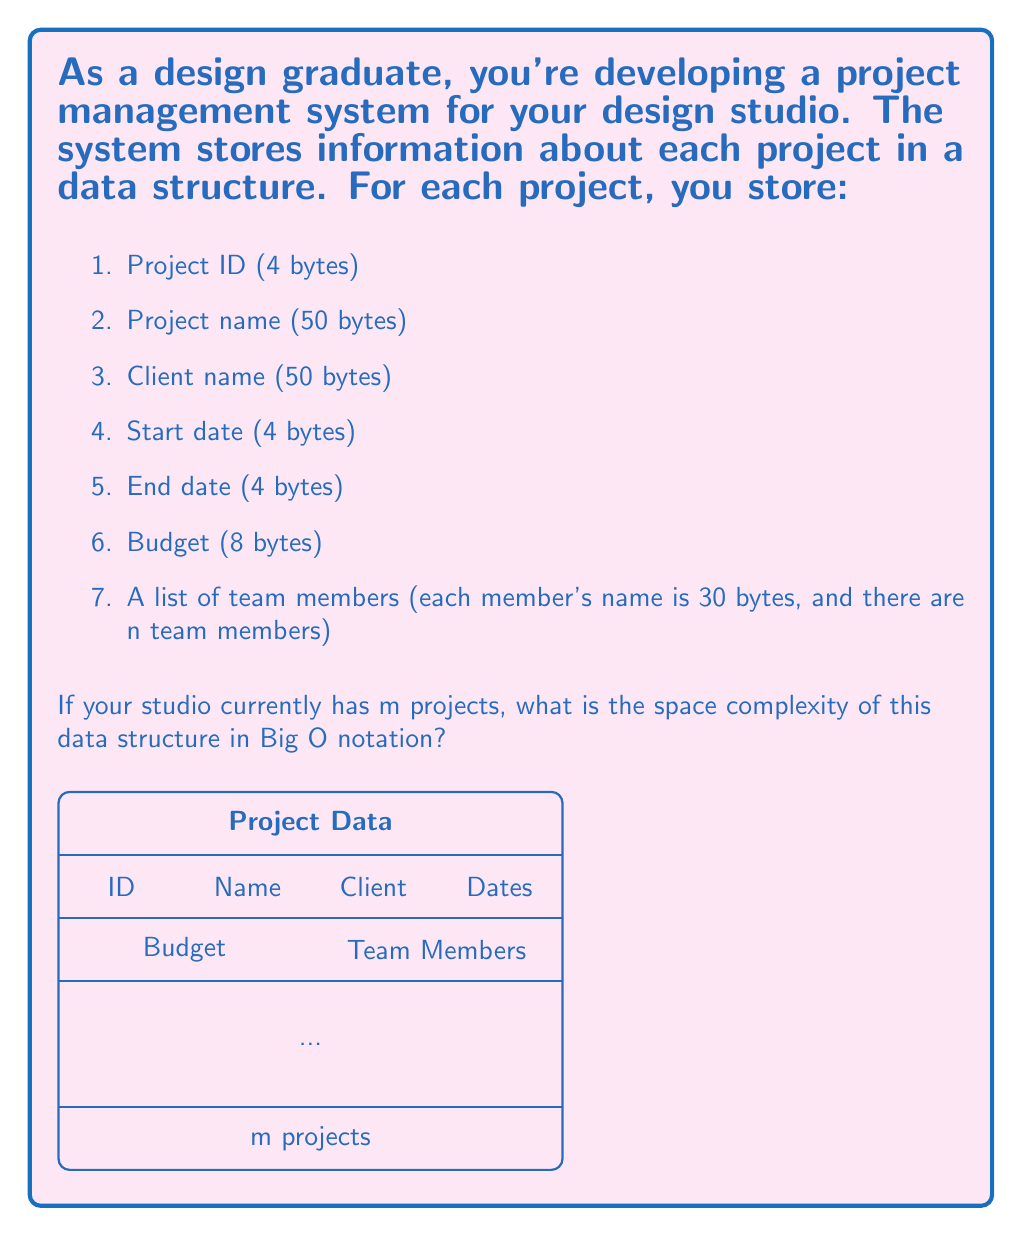Solve this math problem. Let's break down the space complexity analysis step-by-step:

1) First, let's calculate the fixed-size data for each project:
   - Project ID: 4 bytes
   - Project name: 50 bytes
   - Client name: 50 bytes
   - Start date: 4 bytes
   - End date: 4 bytes
   - Budget: 8 bytes
   
   Total fixed-size data per project: $4 + 50 + 50 + 4 + 4 + 8 = 120$ bytes

2) Now, let's consider the variable-size data:
   - Team members: Each member's name takes 30 bytes, and there are n members
   
   Total variable-size data per project: $30n$ bytes

3) So, the total space for one project is: $120 + 30n$ bytes

4) For m projects, the total space would be: $m(120 + 30n)$ bytes

5) Expanding this: $120m + 30mn$ bytes

6) In Big O notation, we ignore constants and focus on the highest order terms. Here, both m and n are variables, so we keep both.

7) Therefore, the space complexity is $O(mn)$

This means that the space complexity grows linearly with both the number of projects (m) and the number of team members per project (n).
Answer: $O(mn)$ 